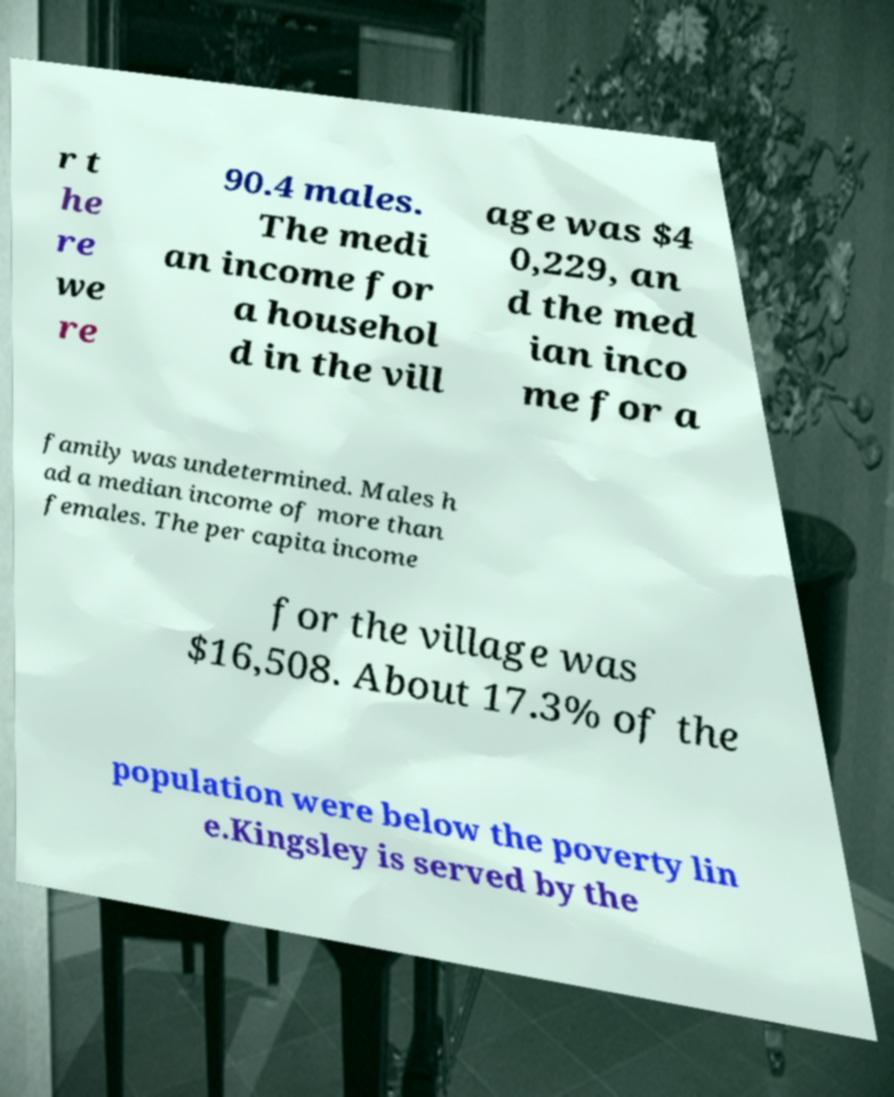Can you read and provide the text displayed in the image?This photo seems to have some interesting text. Can you extract and type it out for me? r t he re we re 90.4 males. The medi an income for a househol d in the vill age was $4 0,229, an d the med ian inco me for a family was undetermined. Males h ad a median income of more than females. The per capita income for the village was $16,508. About 17.3% of the population were below the poverty lin e.Kingsley is served by the 